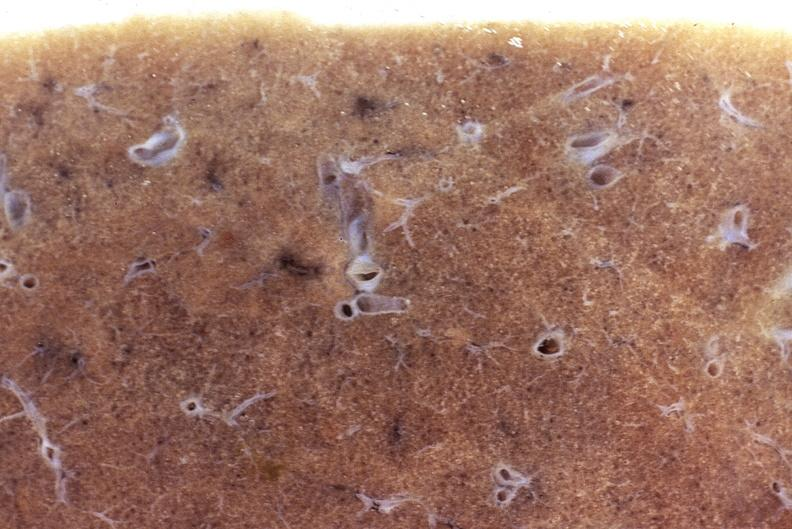does this image show normal lung?
Answer the question using a single word or phrase. Yes 